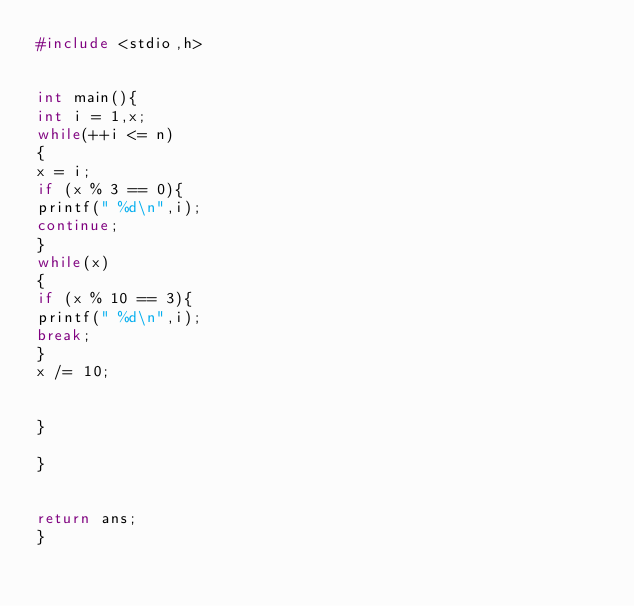<code> <loc_0><loc_0><loc_500><loc_500><_C_>#include <stdio,h>


int main(){
int i = 1,x;
while(++i <= n)
{
x = i;
if (x % 3 == 0){
printf(" %d\n",i);
continue;
}
while(x)
{
if (x % 10 == 3){
printf(" %d\n",i);
break;
}
x /= 10;


}

}


return ans;
}</code> 